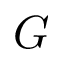<formula> <loc_0><loc_0><loc_500><loc_500>G</formula> 